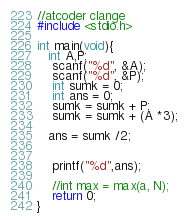<code> <loc_0><loc_0><loc_500><loc_500><_C_>//atcoder clange
#include <stdio.h>

int main(void){
   int A,P;
	scanf("%d", &A);
	scanf("%d", &P);
  	int sumk = 0;
    int ans = 0;
  	sumk = sumk + P;
  	sumk = sumk + (A *3);
  	
   ans = sumk /2;
  

    printf("%d",ans);

    //int max = max(a, N);
    return 0;   
}</code> 